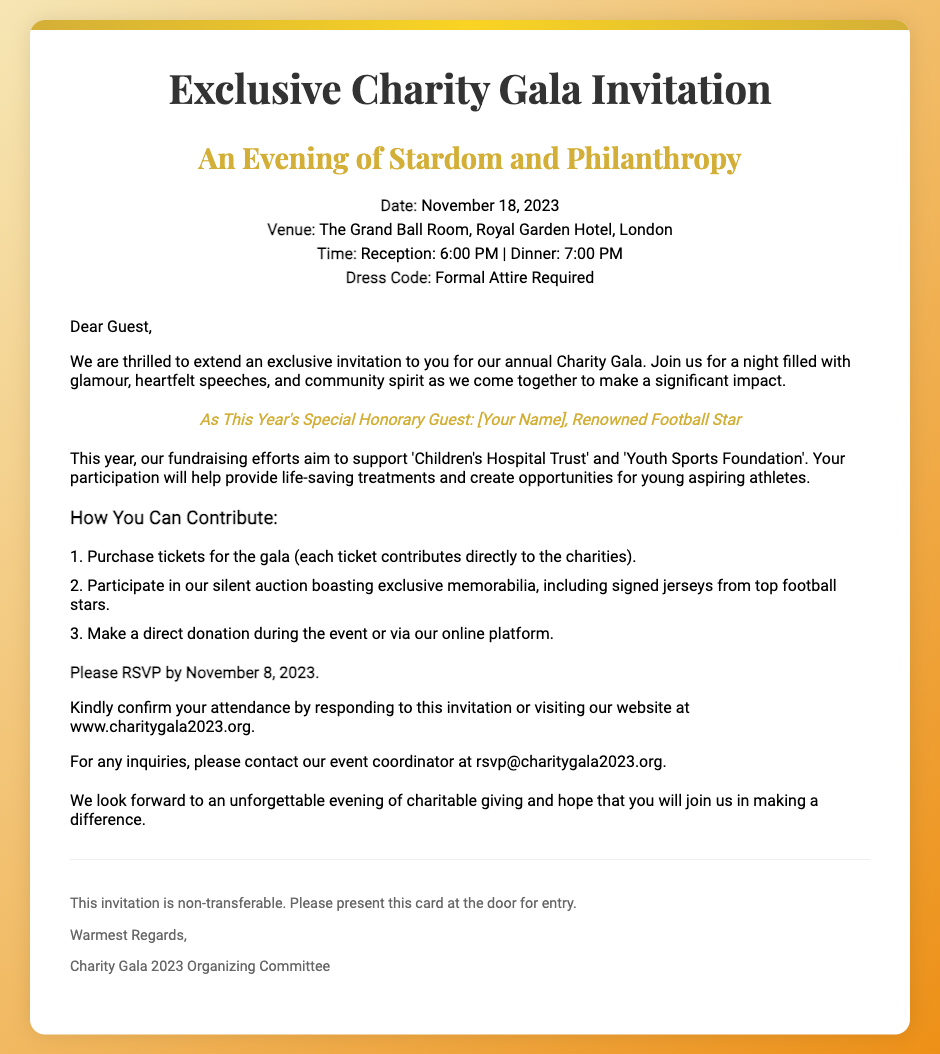What is the date of the event? The document states that the event is on November 18, 2023.
Answer: November 18, 2023 What is the venue for the gala? The RSVP card specifies that the venue is The Grand Ball Room, Royal Garden Hotel, London.
Answer: The Grand Ball Room, Royal Garden Hotel, London What is the required dress code? The document mentions that formal attire is required for the event.
Answer: Formal Attire Required Who is the special honorary guest? The RSVP card highlights that the special honorary guest is [Your Name], a renowned football star.
Answer: [Your Name] How can guests make a direct donation? The document states that guests can make a direct donation during the event or via the online platform.
Answer: During the event or via our online platform What is the deadline for RSVP? The RSVP card indicates that the RSVP deadline is November 8, 2023.
Answer: November 8, 2023 What charities are the fundraising efforts supporting? The document lists that the charities supported are 'Children's Hospital Trust' and 'Youth Sports Foundation'.
Answer: Children's Hospital Trust and Youth Sports Foundation What is the time for dinner? According to the event details, dinner is scheduled for 7:00 PM.
Answer: 7:00 PM What type of auction will occur at the gala? The RSVP card mentions a silent auction featuring exclusive memorabilia.
Answer: Silent auction 